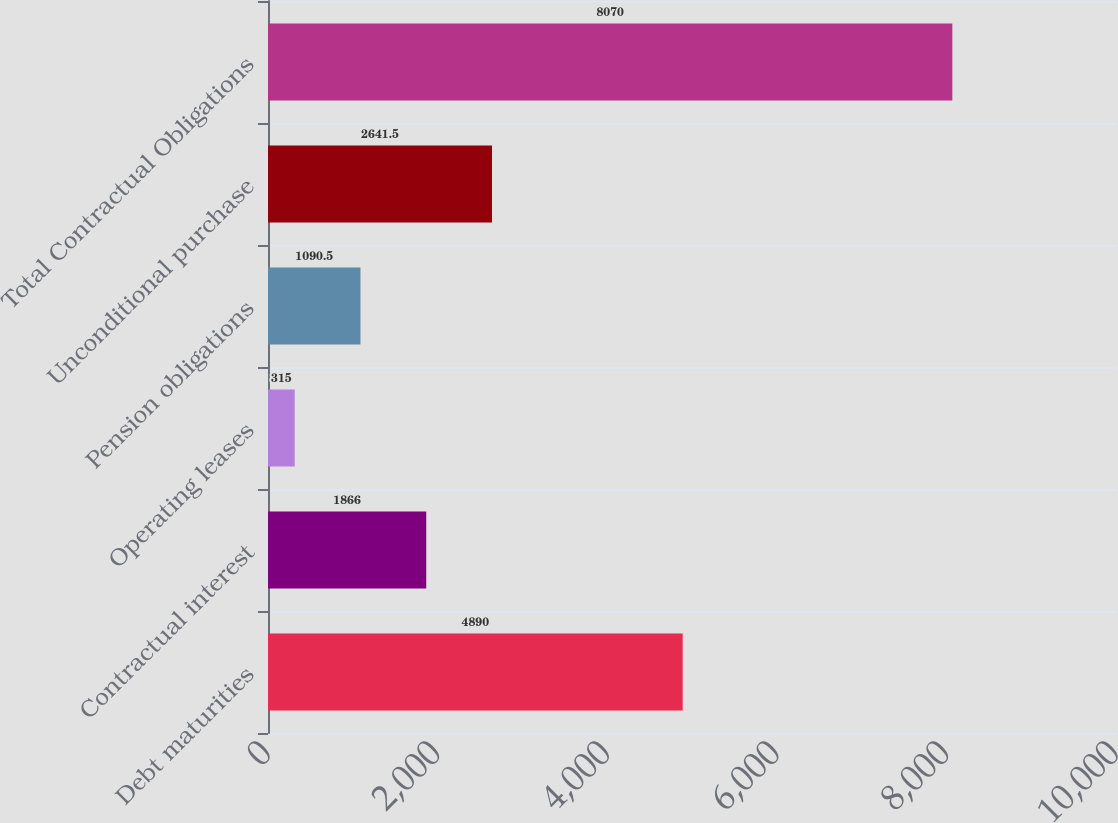Convert chart to OTSL. <chart><loc_0><loc_0><loc_500><loc_500><bar_chart><fcel>Debt maturities<fcel>Contractual interest<fcel>Operating leases<fcel>Pension obligations<fcel>Unconditional purchase<fcel>Total Contractual Obligations<nl><fcel>4890<fcel>1866<fcel>315<fcel>1090.5<fcel>2641.5<fcel>8070<nl></chart> 